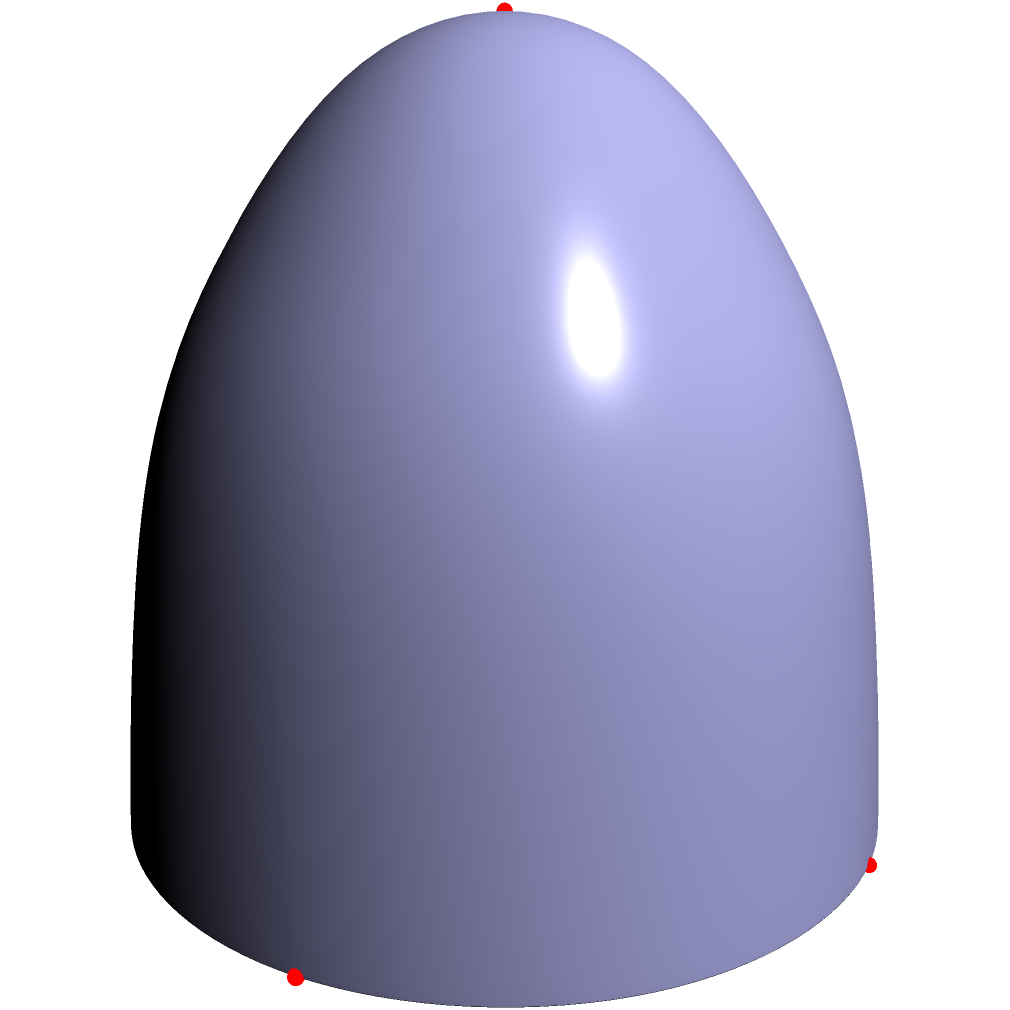A food delivery startup is optimizing its delivery routes by mapping restaurant locations on a spherical surface representing the Earth. If five restaurants are located at the following coordinates on the unit sphere: $(1,0,0)$, $(0,1,0)$, $(-1,0,0)$, $(0,-1,0)$, and $(0,0,1)$, what is the maximum great circle distance between any two restaurants? To solve this problem, we need to follow these steps:

1) Recall that the great circle distance between two points on a unit sphere is given by the arc cosine of the dot product of their position vectors:

   $d = \arccos(\mathbf{a} \cdot \mathbf{b})$

2) We need to calculate the dot product for each pair of restaurants and find the maximum:

   a) $(1,0,0) \cdot (0,1,0) = 0$
   b) $(1,0,0) \cdot (-1,0,0) = -1$
   c) $(1,0,0) \cdot (0,-1,0) = 0$
   d) $(1,0,0) \cdot (0,0,1) = 0$
   e) $(0,1,0) \cdot (-1,0,0) = 0$
   f) $(0,1,0) \cdot (0,-1,0) = -1$
   g) $(0,1,0) \cdot (0,0,1) = 0$
   h) $(-1,0,0) \cdot (0,-1,0) = 0$
   i) $(-1,0,0) \cdot (0,0,1) = 0$
   j) $(0,-1,0) \cdot (0,0,1) = 0$

3) The minimum dot product is -1, which occurs between opposite points on the sphere.

4) The great circle distance is therefore:

   $d = \arccos(-1) = \pi$

5) This is equivalent to half the circumference of the unit sphere, or 180 degrees.
Answer: $\pi$ radians or 180 degrees 